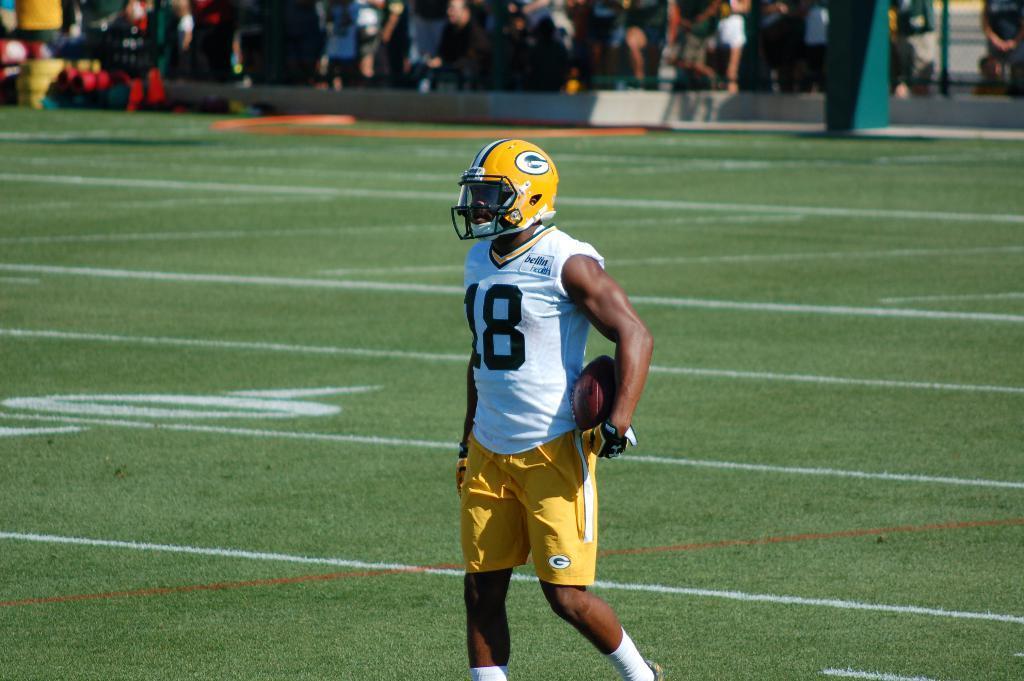Could you give a brief overview of what you see in this image? In this picture in the front there is a man standing and holding a ball. In the center there is grass on the ground. In the background there are persons and there is an object which is green in colour. 